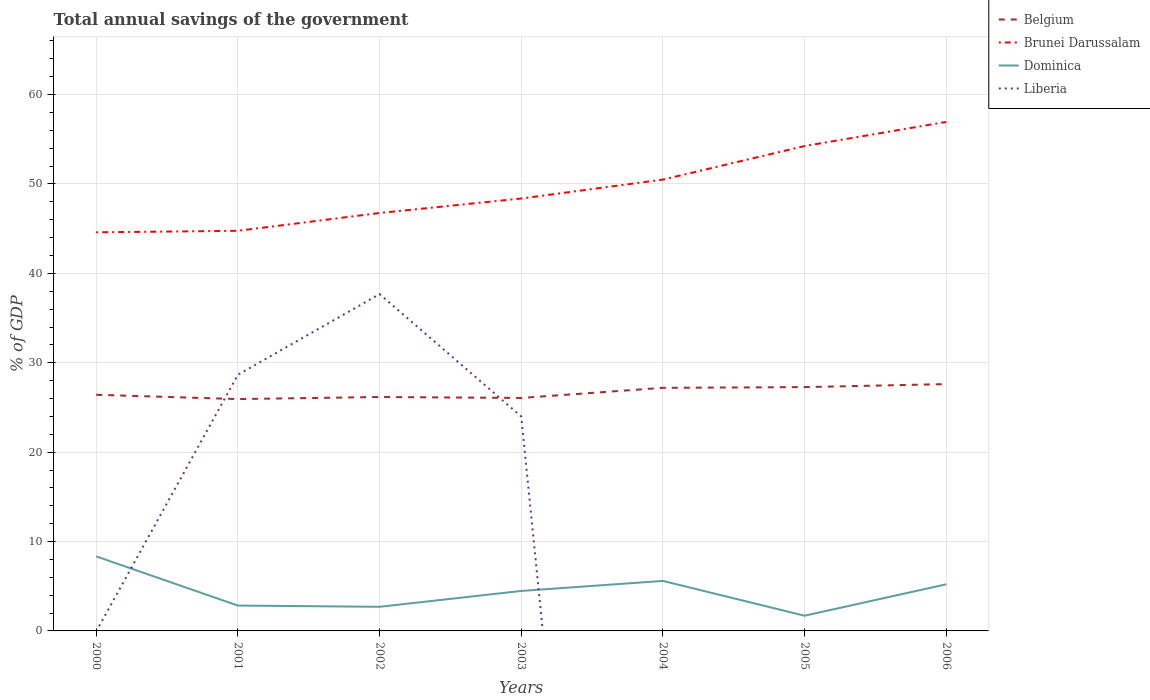Does the line corresponding to Belgium intersect with the line corresponding to Brunei Darussalam?
Your answer should be compact. No. What is the total total annual savings of the government in Dominica in the graph?
Offer a very short reply. -1.77. What is the difference between the highest and the second highest total annual savings of the government in Liberia?
Your answer should be very brief. 37.68. Is the total annual savings of the government in Brunei Darussalam strictly greater than the total annual savings of the government in Belgium over the years?
Provide a succinct answer. No. How many lines are there?
Make the answer very short. 4. Are the values on the major ticks of Y-axis written in scientific E-notation?
Your answer should be very brief. No. Does the graph contain grids?
Provide a succinct answer. Yes. Where does the legend appear in the graph?
Offer a very short reply. Top right. How many legend labels are there?
Offer a terse response. 4. How are the legend labels stacked?
Offer a very short reply. Vertical. What is the title of the graph?
Offer a terse response. Total annual savings of the government. Does "Jamaica" appear as one of the legend labels in the graph?
Make the answer very short. No. What is the label or title of the Y-axis?
Ensure brevity in your answer.  % of GDP. What is the % of GDP in Belgium in 2000?
Ensure brevity in your answer.  26.42. What is the % of GDP in Brunei Darussalam in 2000?
Give a very brief answer. 44.59. What is the % of GDP of Dominica in 2000?
Give a very brief answer. 8.34. What is the % of GDP in Belgium in 2001?
Make the answer very short. 25.94. What is the % of GDP in Brunei Darussalam in 2001?
Your answer should be compact. 44.76. What is the % of GDP in Dominica in 2001?
Your answer should be very brief. 2.84. What is the % of GDP of Liberia in 2001?
Keep it short and to the point. 28.66. What is the % of GDP of Belgium in 2002?
Your response must be concise. 26.17. What is the % of GDP in Brunei Darussalam in 2002?
Your answer should be very brief. 46.76. What is the % of GDP in Dominica in 2002?
Provide a short and direct response. 2.7. What is the % of GDP of Liberia in 2002?
Make the answer very short. 37.68. What is the % of GDP of Belgium in 2003?
Your response must be concise. 26.06. What is the % of GDP in Brunei Darussalam in 2003?
Ensure brevity in your answer.  48.38. What is the % of GDP in Dominica in 2003?
Provide a short and direct response. 4.47. What is the % of GDP in Liberia in 2003?
Give a very brief answer. 23.99. What is the % of GDP of Belgium in 2004?
Your answer should be very brief. 27.2. What is the % of GDP in Brunei Darussalam in 2004?
Provide a succinct answer. 50.49. What is the % of GDP in Dominica in 2004?
Give a very brief answer. 5.59. What is the % of GDP in Liberia in 2004?
Offer a terse response. 0. What is the % of GDP in Belgium in 2005?
Your answer should be very brief. 27.28. What is the % of GDP in Brunei Darussalam in 2005?
Make the answer very short. 54.25. What is the % of GDP of Dominica in 2005?
Your answer should be very brief. 1.7. What is the % of GDP in Liberia in 2005?
Your answer should be compact. 0. What is the % of GDP of Belgium in 2006?
Make the answer very short. 27.61. What is the % of GDP of Brunei Darussalam in 2006?
Make the answer very short. 56.95. What is the % of GDP in Dominica in 2006?
Offer a terse response. 5.22. What is the % of GDP of Liberia in 2006?
Ensure brevity in your answer.  0. Across all years, what is the maximum % of GDP of Belgium?
Provide a short and direct response. 27.61. Across all years, what is the maximum % of GDP of Brunei Darussalam?
Make the answer very short. 56.95. Across all years, what is the maximum % of GDP in Dominica?
Provide a succinct answer. 8.34. Across all years, what is the maximum % of GDP of Liberia?
Make the answer very short. 37.68. Across all years, what is the minimum % of GDP in Belgium?
Offer a terse response. 25.94. Across all years, what is the minimum % of GDP of Brunei Darussalam?
Provide a succinct answer. 44.59. Across all years, what is the minimum % of GDP of Dominica?
Make the answer very short. 1.7. What is the total % of GDP of Belgium in the graph?
Ensure brevity in your answer.  186.67. What is the total % of GDP in Brunei Darussalam in the graph?
Ensure brevity in your answer.  346.17. What is the total % of GDP of Dominica in the graph?
Offer a very short reply. 30.86. What is the total % of GDP of Liberia in the graph?
Offer a very short reply. 90.33. What is the difference between the % of GDP of Belgium in 2000 and that in 2001?
Your answer should be compact. 0.48. What is the difference between the % of GDP in Brunei Darussalam in 2000 and that in 2001?
Your answer should be compact. -0.17. What is the difference between the % of GDP in Dominica in 2000 and that in 2001?
Your answer should be very brief. 5.5. What is the difference between the % of GDP in Belgium in 2000 and that in 2002?
Provide a short and direct response. 0.25. What is the difference between the % of GDP of Brunei Darussalam in 2000 and that in 2002?
Give a very brief answer. -2.16. What is the difference between the % of GDP in Dominica in 2000 and that in 2002?
Offer a terse response. 5.64. What is the difference between the % of GDP in Belgium in 2000 and that in 2003?
Offer a terse response. 0.36. What is the difference between the % of GDP of Brunei Darussalam in 2000 and that in 2003?
Keep it short and to the point. -3.78. What is the difference between the % of GDP of Dominica in 2000 and that in 2003?
Your answer should be very brief. 3.87. What is the difference between the % of GDP in Belgium in 2000 and that in 2004?
Your response must be concise. -0.78. What is the difference between the % of GDP in Dominica in 2000 and that in 2004?
Your answer should be compact. 2.74. What is the difference between the % of GDP in Belgium in 2000 and that in 2005?
Offer a very short reply. -0.86. What is the difference between the % of GDP in Brunei Darussalam in 2000 and that in 2005?
Make the answer very short. -9.65. What is the difference between the % of GDP of Dominica in 2000 and that in 2005?
Offer a terse response. 6.64. What is the difference between the % of GDP in Belgium in 2000 and that in 2006?
Provide a succinct answer. -1.2. What is the difference between the % of GDP of Brunei Darussalam in 2000 and that in 2006?
Your response must be concise. -12.35. What is the difference between the % of GDP in Dominica in 2000 and that in 2006?
Your answer should be very brief. 3.12. What is the difference between the % of GDP in Belgium in 2001 and that in 2002?
Your response must be concise. -0.23. What is the difference between the % of GDP in Brunei Darussalam in 2001 and that in 2002?
Give a very brief answer. -1.99. What is the difference between the % of GDP of Dominica in 2001 and that in 2002?
Make the answer very short. 0.14. What is the difference between the % of GDP in Liberia in 2001 and that in 2002?
Your response must be concise. -9.02. What is the difference between the % of GDP of Belgium in 2001 and that in 2003?
Offer a terse response. -0.12. What is the difference between the % of GDP of Brunei Darussalam in 2001 and that in 2003?
Keep it short and to the point. -3.61. What is the difference between the % of GDP of Dominica in 2001 and that in 2003?
Your answer should be very brief. -1.64. What is the difference between the % of GDP of Liberia in 2001 and that in 2003?
Your answer should be compact. 4.67. What is the difference between the % of GDP in Belgium in 2001 and that in 2004?
Your answer should be compact. -1.26. What is the difference between the % of GDP of Brunei Darussalam in 2001 and that in 2004?
Offer a terse response. -5.73. What is the difference between the % of GDP of Dominica in 2001 and that in 2004?
Offer a very short reply. -2.76. What is the difference between the % of GDP of Belgium in 2001 and that in 2005?
Your response must be concise. -1.34. What is the difference between the % of GDP in Brunei Darussalam in 2001 and that in 2005?
Your answer should be compact. -9.48. What is the difference between the % of GDP in Dominica in 2001 and that in 2005?
Make the answer very short. 1.14. What is the difference between the % of GDP in Belgium in 2001 and that in 2006?
Offer a very short reply. -1.67. What is the difference between the % of GDP of Brunei Darussalam in 2001 and that in 2006?
Provide a succinct answer. -12.18. What is the difference between the % of GDP in Dominica in 2001 and that in 2006?
Provide a succinct answer. -2.38. What is the difference between the % of GDP in Belgium in 2002 and that in 2003?
Ensure brevity in your answer.  0.11. What is the difference between the % of GDP of Brunei Darussalam in 2002 and that in 2003?
Your response must be concise. -1.62. What is the difference between the % of GDP in Dominica in 2002 and that in 2003?
Offer a terse response. -1.77. What is the difference between the % of GDP in Liberia in 2002 and that in 2003?
Ensure brevity in your answer.  13.69. What is the difference between the % of GDP of Belgium in 2002 and that in 2004?
Provide a short and direct response. -1.03. What is the difference between the % of GDP in Brunei Darussalam in 2002 and that in 2004?
Provide a succinct answer. -3.74. What is the difference between the % of GDP of Dominica in 2002 and that in 2004?
Offer a very short reply. -2.9. What is the difference between the % of GDP in Belgium in 2002 and that in 2005?
Provide a short and direct response. -1.11. What is the difference between the % of GDP in Brunei Darussalam in 2002 and that in 2005?
Make the answer very short. -7.49. What is the difference between the % of GDP in Dominica in 2002 and that in 2005?
Offer a very short reply. 1. What is the difference between the % of GDP of Belgium in 2002 and that in 2006?
Offer a terse response. -1.44. What is the difference between the % of GDP in Brunei Darussalam in 2002 and that in 2006?
Offer a very short reply. -10.19. What is the difference between the % of GDP of Dominica in 2002 and that in 2006?
Your answer should be very brief. -2.52. What is the difference between the % of GDP in Belgium in 2003 and that in 2004?
Provide a short and direct response. -1.13. What is the difference between the % of GDP in Brunei Darussalam in 2003 and that in 2004?
Ensure brevity in your answer.  -2.12. What is the difference between the % of GDP of Dominica in 2003 and that in 2004?
Make the answer very short. -1.12. What is the difference between the % of GDP of Belgium in 2003 and that in 2005?
Provide a succinct answer. -1.21. What is the difference between the % of GDP in Brunei Darussalam in 2003 and that in 2005?
Provide a short and direct response. -5.87. What is the difference between the % of GDP of Dominica in 2003 and that in 2005?
Provide a short and direct response. 2.77. What is the difference between the % of GDP of Belgium in 2003 and that in 2006?
Your answer should be compact. -1.55. What is the difference between the % of GDP in Brunei Darussalam in 2003 and that in 2006?
Your answer should be very brief. -8.57. What is the difference between the % of GDP in Dominica in 2003 and that in 2006?
Your answer should be very brief. -0.75. What is the difference between the % of GDP in Belgium in 2004 and that in 2005?
Give a very brief answer. -0.08. What is the difference between the % of GDP in Brunei Darussalam in 2004 and that in 2005?
Give a very brief answer. -3.75. What is the difference between the % of GDP of Dominica in 2004 and that in 2005?
Give a very brief answer. 3.89. What is the difference between the % of GDP of Belgium in 2004 and that in 2006?
Your response must be concise. -0.42. What is the difference between the % of GDP in Brunei Darussalam in 2004 and that in 2006?
Offer a very short reply. -6.45. What is the difference between the % of GDP of Dominica in 2004 and that in 2006?
Ensure brevity in your answer.  0.38. What is the difference between the % of GDP of Belgium in 2005 and that in 2006?
Provide a short and direct response. -0.34. What is the difference between the % of GDP of Brunei Darussalam in 2005 and that in 2006?
Offer a terse response. -2.7. What is the difference between the % of GDP in Dominica in 2005 and that in 2006?
Your response must be concise. -3.52. What is the difference between the % of GDP in Belgium in 2000 and the % of GDP in Brunei Darussalam in 2001?
Provide a short and direct response. -18.34. What is the difference between the % of GDP in Belgium in 2000 and the % of GDP in Dominica in 2001?
Offer a terse response. 23.58. What is the difference between the % of GDP in Belgium in 2000 and the % of GDP in Liberia in 2001?
Provide a short and direct response. -2.24. What is the difference between the % of GDP of Brunei Darussalam in 2000 and the % of GDP of Dominica in 2001?
Keep it short and to the point. 41.76. What is the difference between the % of GDP of Brunei Darussalam in 2000 and the % of GDP of Liberia in 2001?
Give a very brief answer. 15.94. What is the difference between the % of GDP in Dominica in 2000 and the % of GDP in Liberia in 2001?
Offer a very short reply. -20.32. What is the difference between the % of GDP of Belgium in 2000 and the % of GDP of Brunei Darussalam in 2002?
Give a very brief answer. -20.34. What is the difference between the % of GDP of Belgium in 2000 and the % of GDP of Dominica in 2002?
Keep it short and to the point. 23.72. What is the difference between the % of GDP in Belgium in 2000 and the % of GDP in Liberia in 2002?
Make the answer very short. -11.26. What is the difference between the % of GDP of Brunei Darussalam in 2000 and the % of GDP of Dominica in 2002?
Provide a succinct answer. 41.9. What is the difference between the % of GDP of Brunei Darussalam in 2000 and the % of GDP of Liberia in 2002?
Make the answer very short. 6.91. What is the difference between the % of GDP in Dominica in 2000 and the % of GDP in Liberia in 2002?
Make the answer very short. -29.34. What is the difference between the % of GDP of Belgium in 2000 and the % of GDP of Brunei Darussalam in 2003?
Keep it short and to the point. -21.96. What is the difference between the % of GDP in Belgium in 2000 and the % of GDP in Dominica in 2003?
Provide a succinct answer. 21.95. What is the difference between the % of GDP of Belgium in 2000 and the % of GDP of Liberia in 2003?
Make the answer very short. 2.43. What is the difference between the % of GDP in Brunei Darussalam in 2000 and the % of GDP in Dominica in 2003?
Make the answer very short. 40.12. What is the difference between the % of GDP in Brunei Darussalam in 2000 and the % of GDP in Liberia in 2003?
Your response must be concise. 20.6. What is the difference between the % of GDP in Dominica in 2000 and the % of GDP in Liberia in 2003?
Keep it short and to the point. -15.65. What is the difference between the % of GDP of Belgium in 2000 and the % of GDP of Brunei Darussalam in 2004?
Provide a succinct answer. -24.08. What is the difference between the % of GDP of Belgium in 2000 and the % of GDP of Dominica in 2004?
Ensure brevity in your answer.  20.82. What is the difference between the % of GDP in Brunei Darussalam in 2000 and the % of GDP in Dominica in 2004?
Your answer should be very brief. 39. What is the difference between the % of GDP in Belgium in 2000 and the % of GDP in Brunei Darussalam in 2005?
Keep it short and to the point. -27.83. What is the difference between the % of GDP of Belgium in 2000 and the % of GDP of Dominica in 2005?
Provide a short and direct response. 24.72. What is the difference between the % of GDP of Brunei Darussalam in 2000 and the % of GDP of Dominica in 2005?
Give a very brief answer. 42.9. What is the difference between the % of GDP of Belgium in 2000 and the % of GDP of Brunei Darussalam in 2006?
Provide a succinct answer. -30.53. What is the difference between the % of GDP of Belgium in 2000 and the % of GDP of Dominica in 2006?
Your answer should be very brief. 21.2. What is the difference between the % of GDP of Brunei Darussalam in 2000 and the % of GDP of Dominica in 2006?
Ensure brevity in your answer.  39.38. What is the difference between the % of GDP in Belgium in 2001 and the % of GDP in Brunei Darussalam in 2002?
Give a very brief answer. -20.82. What is the difference between the % of GDP in Belgium in 2001 and the % of GDP in Dominica in 2002?
Make the answer very short. 23.24. What is the difference between the % of GDP of Belgium in 2001 and the % of GDP of Liberia in 2002?
Ensure brevity in your answer.  -11.74. What is the difference between the % of GDP of Brunei Darussalam in 2001 and the % of GDP of Dominica in 2002?
Provide a succinct answer. 42.06. What is the difference between the % of GDP in Brunei Darussalam in 2001 and the % of GDP in Liberia in 2002?
Your response must be concise. 7.08. What is the difference between the % of GDP in Dominica in 2001 and the % of GDP in Liberia in 2002?
Provide a succinct answer. -34.85. What is the difference between the % of GDP of Belgium in 2001 and the % of GDP of Brunei Darussalam in 2003?
Provide a short and direct response. -22.44. What is the difference between the % of GDP of Belgium in 2001 and the % of GDP of Dominica in 2003?
Your answer should be compact. 21.47. What is the difference between the % of GDP in Belgium in 2001 and the % of GDP in Liberia in 2003?
Your answer should be very brief. 1.95. What is the difference between the % of GDP of Brunei Darussalam in 2001 and the % of GDP of Dominica in 2003?
Ensure brevity in your answer.  40.29. What is the difference between the % of GDP of Brunei Darussalam in 2001 and the % of GDP of Liberia in 2003?
Ensure brevity in your answer.  20.77. What is the difference between the % of GDP in Dominica in 2001 and the % of GDP in Liberia in 2003?
Your response must be concise. -21.16. What is the difference between the % of GDP of Belgium in 2001 and the % of GDP of Brunei Darussalam in 2004?
Your answer should be very brief. -24.56. What is the difference between the % of GDP in Belgium in 2001 and the % of GDP in Dominica in 2004?
Your response must be concise. 20.34. What is the difference between the % of GDP of Brunei Darussalam in 2001 and the % of GDP of Dominica in 2004?
Offer a terse response. 39.17. What is the difference between the % of GDP of Belgium in 2001 and the % of GDP of Brunei Darussalam in 2005?
Offer a very short reply. -28.31. What is the difference between the % of GDP of Belgium in 2001 and the % of GDP of Dominica in 2005?
Your answer should be compact. 24.24. What is the difference between the % of GDP in Brunei Darussalam in 2001 and the % of GDP in Dominica in 2005?
Provide a succinct answer. 43.06. What is the difference between the % of GDP in Belgium in 2001 and the % of GDP in Brunei Darussalam in 2006?
Offer a very short reply. -31.01. What is the difference between the % of GDP of Belgium in 2001 and the % of GDP of Dominica in 2006?
Make the answer very short. 20.72. What is the difference between the % of GDP in Brunei Darussalam in 2001 and the % of GDP in Dominica in 2006?
Provide a short and direct response. 39.54. What is the difference between the % of GDP of Belgium in 2002 and the % of GDP of Brunei Darussalam in 2003?
Keep it short and to the point. -22.21. What is the difference between the % of GDP in Belgium in 2002 and the % of GDP in Dominica in 2003?
Keep it short and to the point. 21.7. What is the difference between the % of GDP in Belgium in 2002 and the % of GDP in Liberia in 2003?
Make the answer very short. 2.18. What is the difference between the % of GDP in Brunei Darussalam in 2002 and the % of GDP in Dominica in 2003?
Your answer should be compact. 42.28. What is the difference between the % of GDP of Brunei Darussalam in 2002 and the % of GDP of Liberia in 2003?
Your answer should be very brief. 22.76. What is the difference between the % of GDP in Dominica in 2002 and the % of GDP in Liberia in 2003?
Make the answer very short. -21.29. What is the difference between the % of GDP of Belgium in 2002 and the % of GDP of Brunei Darussalam in 2004?
Keep it short and to the point. -24.33. What is the difference between the % of GDP in Belgium in 2002 and the % of GDP in Dominica in 2004?
Your answer should be compact. 20.57. What is the difference between the % of GDP of Brunei Darussalam in 2002 and the % of GDP of Dominica in 2004?
Keep it short and to the point. 41.16. What is the difference between the % of GDP in Belgium in 2002 and the % of GDP in Brunei Darussalam in 2005?
Keep it short and to the point. -28.08. What is the difference between the % of GDP of Belgium in 2002 and the % of GDP of Dominica in 2005?
Provide a succinct answer. 24.47. What is the difference between the % of GDP of Brunei Darussalam in 2002 and the % of GDP of Dominica in 2005?
Offer a very short reply. 45.06. What is the difference between the % of GDP in Belgium in 2002 and the % of GDP in Brunei Darussalam in 2006?
Offer a very short reply. -30.78. What is the difference between the % of GDP in Belgium in 2002 and the % of GDP in Dominica in 2006?
Your answer should be very brief. 20.95. What is the difference between the % of GDP in Brunei Darussalam in 2002 and the % of GDP in Dominica in 2006?
Ensure brevity in your answer.  41.54. What is the difference between the % of GDP in Belgium in 2003 and the % of GDP in Brunei Darussalam in 2004?
Ensure brevity in your answer.  -24.43. What is the difference between the % of GDP of Belgium in 2003 and the % of GDP of Dominica in 2004?
Your answer should be very brief. 20.47. What is the difference between the % of GDP in Brunei Darussalam in 2003 and the % of GDP in Dominica in 2004?
Keep it short and to the point. 42.78. What is the difference between the % of GDP in Belgium in 2003 and the % of GDP in Brunei Darussalam in 2005?
Offer a terse response. -28.18. What is the difference between the % of GDP of Belgium in 2003 and the % of GDP of Dominica in 2005?
Provide a short and direct response. 24.36. What is the difference between the % of GDP in Brunei Darussalam in 2003 and the % of GDP in Dominica in 2005?
Your answer should be compact. 46.68. What is the difference between the % of GDP in Belgium in 2003 and the % of GDP in Brunei Darussalam in 2006?
Offer a very short reply. -30.88. What is the difference between the % of GDP in Belgium in 2003 and the % of GDP in Dominica in 2006?
Your response must be concise. 20.84. What is the difference between the % of GDP of Brunei Darussalam in 2003 and the % of GDP of Dominica in 2006?
Your answer should be compact. 43.16. What is the difference between the % of GDP in Belgium in 2004 and the % of GDP in Brunei Darussalam in 2005?
Your answer should be compact. -27.05. What is the difference between the % of GDP of Belgium in 2004 and the % of GDP of Dominica in 2005?
Your response must be concise. 25.5. What is the difference between the % of GDP of Brunei Darussalam in 2004 and the % of GDP of Dominica in 2005?
Keep it short and to the point. 48.8. What is the difference between the % of GDP of Belgium in 2004 and the % of GDP of Brunei Darussalam in 2006?
Offer a very short reply. -29.75. What is the difference between the % of GDP of Belgium in 2004 and the % of GDP of Dominica in 2006?
Your answer should be very brief. 21.98. What is the difference between the % of GDP in Brunei Darussalam in 2004 and the % of GDP in Dominica in 2006?
Make the answer very short. 45.28. What is the difference between the % of GDP in Belgium in 2005 and the % of GDP in Brunei Darussalam in 2006?
Make the answer very short. -29.67. What is the difference between the % of GDP in Belgium in 2005 and the % of GDP in Dominica in 2006?
Keep it short and to the point. 22.06. What is the difference between the % of GDP of Brunei Darussalam in 2005 and the % of GDP of Dominica in 2006?
Offer a terse response. 49.03. What is the average % of GDP in Belgium per year?
Keep it short and to the point. 26.67. What is the average % of GDP in Brunei Darussalam per year?
Ensure brevity in your answer.  49.45. What is the average % of GDP in Dominica per year?
Offer a very short reply. 4.41. What is the average % of GDP of Liberia per year?
Provide a short and direct response. 12.9. In the year 2000, what is the difference between the % of GDP in Belgium and % of GDP in Brunei Darussalam?
Provide a short and direct response. -18.18. In the year 2000, what is the difference between the % of GDP of Belgium and % of GDP of Dominica?
Your answer should be very brief. 18.08. In the year 2000, what is the difference between the % of GDP of Brunei Darussalam and % of GDP of Dominica?
Offer a terse response. 36.26. In the year 2001, what is the difference between the % of GDP of Belgium and % of GDP of Brunei Darussalam?
Your answer should be compact. -18.82. In the year 2001, what is the difference between the % of GDP of Belgium and % of GDP of Dominica?
Make the answer very short. 23.1. In the year 2001, what is the difference between the % of GDP in Belgium and % of GDP in Liberia?
Keep it short and to the point. -2.72. In the year 2001, what is the difference between the % of GDP of Brunei Darussalam and % of GDP of Dominica?
Ensure brevity in your answer.  41.93. In the year 2001, what is the difference between the % of GDP in Brunei Darussalam and % of GDP in Liberia?
Your answer should be compact. 16.1. In the year 2001, what is the difference between the % of GDP in Dominica and % of GDP in Liberia?
Your response must be concise. -25.82. In the year 2002, what is the difference between the % of GDP of Belgium and % of GDP of Brunei Darussalam?
Ensure brevity in your answer.  -20.59. In the year 2002, what is the difference between the % of GDP in Belgium and % of GDP in Dominica?
Keep it short and to the point. 23.47. In the year 2002, what is the difference between the % of GDP of Belgium and % of GDP of Liberia?
Offer a terse response. -11.51. In the year 2002, what is the difference between the % of GDP of Brunei Darussalam and % of GDP of Dominica?
Your answer should be compact. 44.06. In the year 2002, what is the difference between the % of GDP of Brunei Darussalam and % of GDP of Liberia?
Your response must be concise. 9.07. In the year 2002, what is the difference between the % of GDP of Dominica and % of GDP of Liberia?
Give a very brief answer. -34.98. In the year 2003, what is the difference between the % of GDP of Belgium and % of GDP of Brunei Darussalam?
Keep it short and to the point. -22.31. In the year 2003, what is the difference between the % of GDP in Belgium and % of GDP in Dominica?
Keep it short and to the point. 21.59. In the year 2003, what is the difference between the % of GDP in Belgium and % of GDP in Liberia?
Provide a short and direct response. 2.07. In the year 2003, what is the difference between the % of GDP of Brunei Darussalam and % of GDP of Dominica?
Keep it short and to the point. 43.9. In the year 2003, what is the difference between the % of GDP in Brunei Darussalam and % of GDP in Liberia?
Offer a very short reply. 24.38. In the year 2003, what is the difference between the % of GDP of Dominica and % of GDP of Liberia?
Your answer should be very brief. -19.52. In the year 2004, what is the difference between the % of GDP of Belgium and % of GDP of Brunei Darussalam?
Offer a terse response. -23.3. In the year 2004, what is the difference between the % of GDP of Belgium and % of GDP of Dominica?
Provide a short and direct response. 21.6. In the year 2004, what is the difference between the % of GDP of Brunei Darussalam and % of GDP of Dominica?
Provide a short and direct response. 44.9. In the year 2005, what is the difference between the % of GDP of Belgium and % of GDP of Brunei Darussalam?
Give a very brief answer. -26.97. In the year 2005, what is the difference between the % of GDP of Belgium and % of GDP of Dominica?
Offer a very short reply. 25.58. In the year 2005, what is the difference between the % of GDP in Brunei Darussalam and % of GDP in Dominica?
Your answer should be compact. 52.55. In the year 2006, what is the difference between the % of GDP in Belgium and % of GDP in Brunei Darussalam?
Make the answer very short. -29.33. In the year 2006, what is the difference between the % of GDP of Belgium and % of GDP of Dominica?
Provide a short and direct response. 22.39. In the year 2006, what is the difference between the % of GDP in Brunei Darussalam and % of GDP in Dominica?
Provide a short and direct response. 51.73. What is the ratio of the % of GDP in Belgium in 2000 to that in 2001?
Offer a terse response. 1.02. What is the ratio of the % of GDP of Dominica in 2000 to that in 2001?
Give a very brief answer. 2.94. What is the ratio of the % of GDP in Belgium in 2000 to that in 2002?
Your answer should be very brief. 1.01. What is the ratio of the % of GDP of Brunei Darussalam in 2000 to that in 2002?
Provide a succinct answer. 0.95. What is the ratio of the % of GDP in Dominica in 2000 to that in 2002?
Offer a terse response. 3.09. What is the ratio of the % of GDP of Belgium in 2000 to that in 2003?
Make the answer very short. 1.01. What is the ratio of the % of GDP of Brunei Darussalam in 2000 to that in 2003?
Your answer should be very brief. 0.92. What is the ratio of the % of GDP in Dominica in 2000 to that in 2003?
Give a very brief answer. 1.86. What is the ratio of the % of GDP in Belgium in 2000 to that in 2004?
Ensure brevity in your answer.  0.97. What is the ratio of the % of GDP in Brunei Darussalam in 2000 to that in 2004?
Your response must be concise. 0.88. What is the ratio of the % of GDP in Dominica in 2000 to that in 2004?
Your answer should be very brief. 1.49. What is the ratio of the % of GDP in Belgium in 2000 to that in 2005?
Offer a terse response. 0.97. What is the ratio of the % of GDP of Brunei Darussalam in 2000 to that in 2005?
Your answer should be very brief. 0.82. What is the ratio of the % of GDP in Dominica in 2000 to that in 2005?
Your answer should be compact. 4.9. What is the ratio of the % of GDP in Belgium in 2000 to that in 2006?
Offer a very short reply. 0.96. What is the ratio of the % of GDP of Brunei Darussalam in 2000 to that in 2006?
Ensure brevity in your answer.  0.78. What is the ratio of the % of GDP of Dominica in 2000 to that in 2006?
Give a very brief answer. 1.6. What is the ratio of the % of GDP in Brunei Darussalam in 2001 to that in 2002?
Your answer should be compact. 0.96. What is the ratio of the % of GDP in Dominica in 2001 to that in 2002?
Your response must be concise. 1.05. What is the ratio of the % of GDP of Liberia in 2001 to that in 2002?
Provide a succinct answer. 0.76. What is the ratio of the % of GDP of Brunei Darussalam in 2001 to that in 2003?
Offer a very short reply. 0.93. What is the ratio of the % of GDP of Dominica in 2001 to that in 2003?
Keep it short and to the point. 0.63. What is the ratio of the % of GDP of Liberia in 2001 to that in 2003?
Provide a short and direct response. 1.19. What is the ratio of the % of GDP in Belgium in 2001 to that in 2004?
Make the answer very short. 0.95. What is the ratio of the % of GDP in Brunei Darussalam in 2001 to that in 2004?
Your answer should be compact. 0.89. What is the ratio of the % of GDP in Dominica in 2001 to that in 2004?
Ensure brevity in your answer.  0.51. What is the ratio of the % of GDP in Belgium in 2001 to that in 2005?
Give a very brief answer. 0.95. What is the ratio of the % of GDP of Brunei Darussalam in 2001 to that in 2005?
Provide a short and direct response. 0.83. What is the ratio of the % of GDP in Dominica in 2001 to that in 2005?
Keep it short and to the point. 1.67. What is the ratio of the % of GDP in Belgium in 2001 to that in 2006?
Ensure brevity in your answer.  0.94. What is the ratio of the % of GDP of Brunei Darussalam in 2001 to that in 2006?
Make the answer very short. 0.79. What is the ratio of the % of GDP in Dominica in 2001 to that in 2006?
Your answer should be very brief. 0.54. What is the ratio of the % of GDP in Brunei Darussalam in 2002 to that in 2003?
Offer a very short reply. 0.97. What is the ratio of the % of GDP of Dominica in 2002 to that in 2003?
Give a very brief answer. 0.6. What is the ratio of the % of GDP in Liberia in 2002 to that in 2003?
Make the answer very short. 1.57. What is the ratio of the % of GDP in Belgium in 2002 to that in 2004?
Your response must be concise. 0.96. What is the ratio of the % of GDP of Brunei Darussalam in 2002 to that in 2004?
Your response must be concise. 0.93. What is the ratio of the % of GDP of Dominica in 2002 to that in 2004?
Give a very brief answer. 0.48. What is the ratio of the % of GDP in Belgium in 2002 to that in 2005?
Provide a succinct answer. 0.96. What is the ratio of the % of GDP in Brunei Darussalam in 2002 to that in 2005?
Offer a very short reply. 0.86. What is the ratio of the % of GDP in Dominica in 2002 to that in 2005?
Provide a succinct answer. 1.59. What is the ratio of the % of GDP in Belgium in 2002 to that in 2006?
Offer a terse response. 0.95. What is the ratio of the % of GDP of Brunei Darussalam in 2002 to that in 2006?
Offer a very short reply. 0.82. What is the ratio of the % of GDP in Dominica in 2002 to that in 2006?
Your answer should be compact. 0.52. What is the ratio of the % of GDP in Belgium in 2003 to that in 2004?
Your answer should be compact. 0.96. What is the ratio of the % of GDP in Brunei Darussalam in 2003 to that in 2004?
Offer a terse response. 0.96. What is the ratio of the % of GDP in Dominica in 2003 to that in 2004?
Your answer should be compact. 0.8. What is the ratio of the % of GDP in Belgium in 2003 to that in 2005?
Ensure brevity in your answer.  0.96. What is the ratio of the % of GDP in Brunei Darussalam in 2003 to that in 2005?
Provide a succinct answer. 0.89. What is the ratio of the % of GDP in Dominica in 2003 to that in 2005?
Ensure brevity in your answer.  2.63. What is the ratio of the % of GDP in Belgium in 2003 to that in 2006?
Your answer should be compact. 0.94. What is the ratio of the % of GDP of Brunei Darussalam in 2003 to that in 2006?
Your response must be concise. 0.85. What is the ratio of the % of GDP in Dominica in 2003 to that in 2006?
Offer a terse response. 0.86. What is the ratio of the % of GDP of Brunei Darussalam in 2004 to that in 2005?
Provide a succinct answer. 0.93. What is the ratio of the % of GDP of Dominica in 2004 to that in 2005?
Offer a terse response. 3.29. What is the ratio of the % of GDP of Belgium in 2004 to that in 2006?
Keep it short and to the point. 0.98. What is the ratio of the % of GDP in Brunei Darussalam in 2004 to that in 2006?
Your answer should be compact. 0.89. What is the ratio of the % of GDP in Dominica in 2004 to that in 2006?
Make the answer very short. 1.07. What is the ratio of the % of GDP in Brunei Darussalam in 2005 to that in 2006?
Ensure brevity in your answer.  0.95. What is the ratio of the % of GDP of Dominica in 2005 to that in 2006?
Offer a very short reply. 0.33. What is the difference between the highest and the second highest % of GDP in Belgium?
Keep it short and to the point. 0.34. What is the difference between the highest and the second highest % of GDP of Brunei Darussalam?
Your answer should be very brief. 2.7. What is the difference between the highest and the second highest % of GDP of Dominica?
Ensure brevity in your answer.  2.74. What is the difference between the highest and the second highest % of GDP in Liberia?
Your response must be concise. 9.02. What is the difference between the highest and the lowest % of GDP in Belgium?
Your answer should be compact. 1.67. What is the difference between the highest and the lowest % of GDP in Brunei Darussalam?
Offer a terse response. 12.35. What is the difference between the highest and the lowest % of GDP in Dominica?
Give a very brief answer. 6.64. What is the difference between the highest and the lowest % of GDP of Liberia?
Keep it short and to the point. 37.68. 